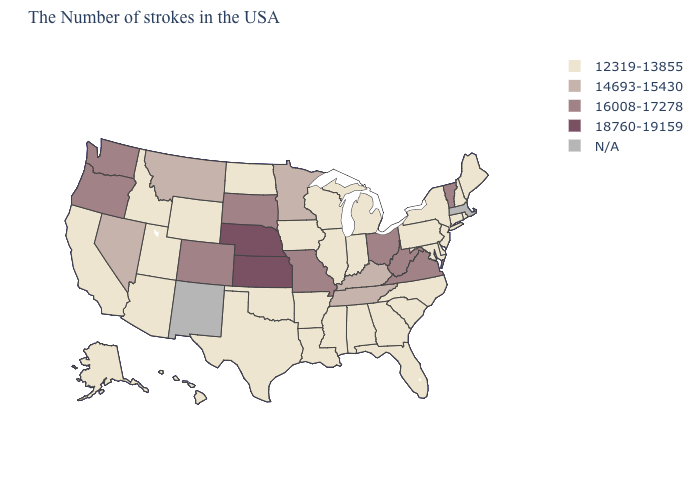Name the states that have a value in the range N/A?
Give a very brief answer. Massachusetts, New Mexico. What is the highest value in the West ?
Quick response, please. 16008-17278. Does the map have missing data?
Short answer required. Yes. What is the value of Georgia?
Keep it brief. 12319-13855. Name the states that have a value in the range N/A?
Concise answer only. Massachusetts, New Mexico. Among the states that border Rhode Island , which have the highest value?
Answer briefly. Connecticut. Name the states that have a value in the range 14693-15430?
Short answer required. Kentucky, Tennessee, Minnesota, Montana, Nevada. Among the states that border Kentucky , which have the highest value?
Answer briefly. Virginia, West Virginia, Ohio, Missouri. Which states have the lowest value in the USA?
Be succinct. Maine, Rhode Island, New Hampshire, Connecticut, New York, New Jersey, Delaware, Maryland, Pennsylvania, North Carolina, South Carolina, Florida, Georgia, Michigan, Indiana, Alabama, Wisconsin, Illinois, Mississippi, Louisiana, Arkansas, Iowa, Oklahoma, Texas, North Dakota, Wyoming, Utah, Arizona, Idaho, California, Alaska, Hawaii. What is the lowest value in states that border Virginia?
Quick response, please. 12319-13855. Name the states that have a value in the range 14693-15430?
Concise answer only. Kentucky, Tennessee, Minnesota, Montana, Nevada. What is the highest value in the USA?
Keep it brief. 18760-19159. Name the states that have a value in the range 18760-19159?
Be succinct. Kansas, Nebraska. What is the value of California?
Answer briefly. 12319-13855. 